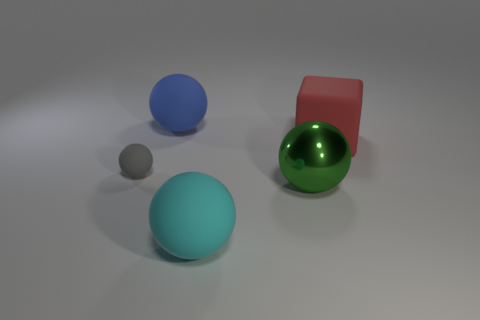The red matte object has what size?
Offer a very short reply. Large. There is a small thing; how many large green balls are in front of it?
Ensure brevity in your answer.  1. There is a big red thing that is the same material as the blue object; what shape is it?
Give a very brief answer. Cube. Is the number of blocks that are in front of the green metal object less than the number of gray spheres on the right side of the matte cube?
Your answer should be very brief. No. Are there more big blue matte spheres than metal blocks?
Offer a terse response. Yes. What is the material of the small sphere?
Ensure brevity in your answer.  Rubber. There is a large matte thing that is on the right side of the green metal sphere; what is its color?
Offer a very short reply. Red. Are there more small balls that are to the left of the small gray matte ball than balls to the right of the large cyan matte ball?
Your answer should be compact. No. What is the size of the matte thing that is on the right side of the large matte object in front of the large ball on the right side of the cyan rubber object?
Your answer should be compact. Large. Is there a shiny cube of the same color as the large metal thing?
Offer a terse response. No. 